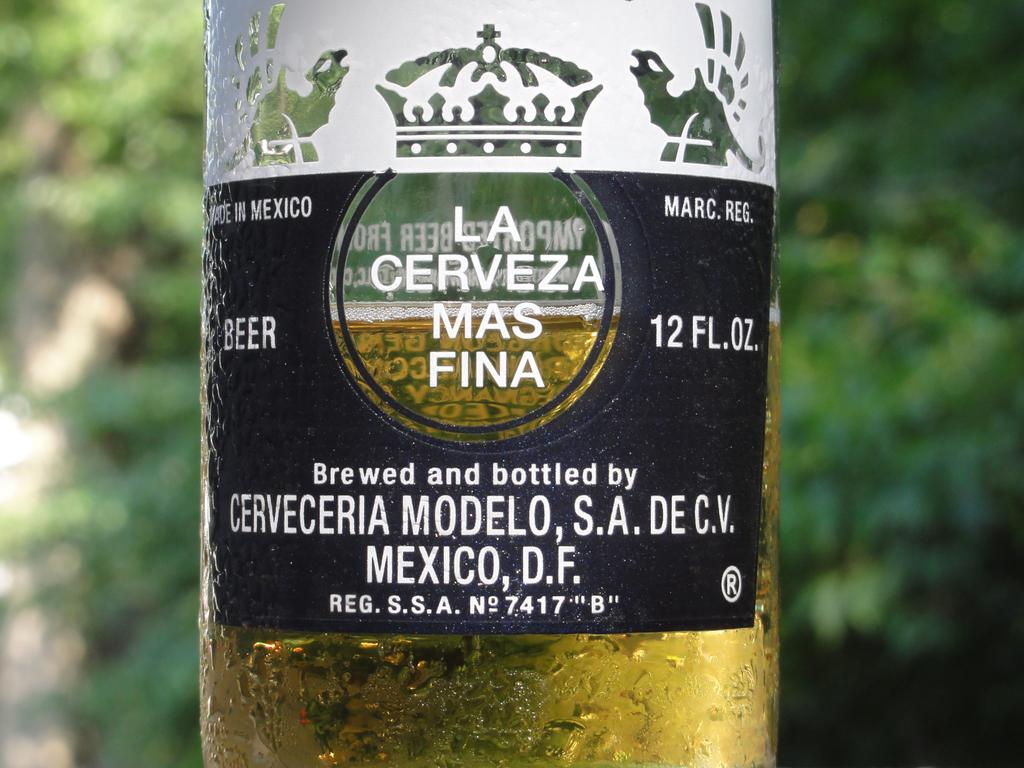Where was the image taken? The image was clicked outside. What can be seen in the image besides the outdoor setting? There is a beer bottle in the image. Are there any distinguishing features on the beer bottle? Yes, there is a sticker on the beer bottle. What does the text on the sticker say? The sticker has text that says 'cerveceria modelo S. A DE. CV'. What month is it in the image? The image does not provide any information about the month, as it only shows a beer bottle with a sticker. Can you tell me how many carts are in the image? There are no carts present in the image; it only features a beer bottle with a sticker. 